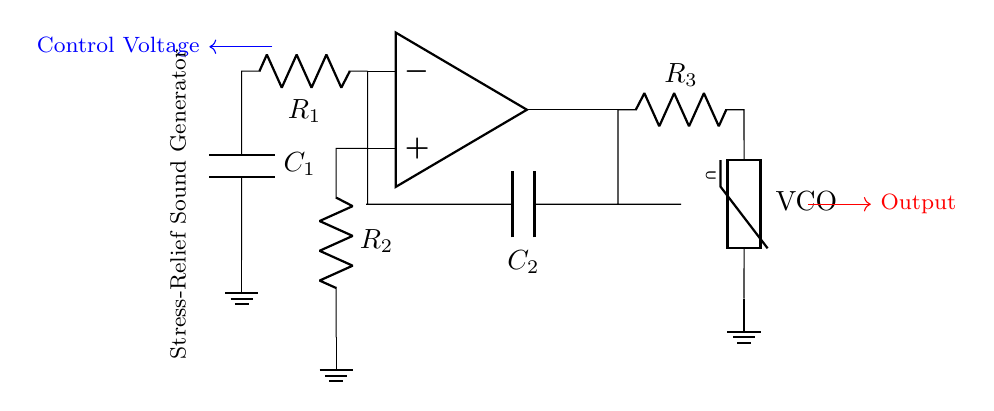What type of circuit is this? This circuit is an oscillator, as indicated by the presence of an operational amplifier and components designed for feedback and frequency control. Oscillators produce a repetitive signal, often used in applications like sound generation.
Answer: Oscillator What does R1 represent in the circuit? R1 is a resistor in the feedback loop of the operational amplifier. It is used for stabilizing the gain of the circuit, which plays a crucial role in determining the frequency of oscillation.
Answer: Resistor What is the function of the control voltage in this circuit? The control voltage adjusts the frequency of the oscillation produced by the circuit. It modifies the behavior of components like the varistor, thus allowing the sound generator to produce different pitches or tones.
Answer: Adjusts frequency How many capacitors are present in this circuit? There are two capacitors, C1 and C2, shown in the circuit. Both capacitors are connected in specific ways that contribute to the timing and frequency characteristics of the oscillator.
Answer: Two What component type is VCO in this circuit? VCO stands for voltage-controlled oscillator, indicating that this component adjusts its output frequency based on the input control voltage. It plays a central role in allowing for variable pitch in the sound produced.
Answer: Varistor Which component influences the sound output according to the control voltage? The varistor influences the sound output, as it is designed to change its resistance based on the voltage applied, thereby affecting the oscillation frequency and resulting sound waves.
Answer: Varistor What is the primary purpose of this oscillator circuit? The primary purpose of this oscillator circuit is to generate sound for stress-relief applications, such as in sound machines designed to produce calming effects.
Answer: Stress-relief sound generator 